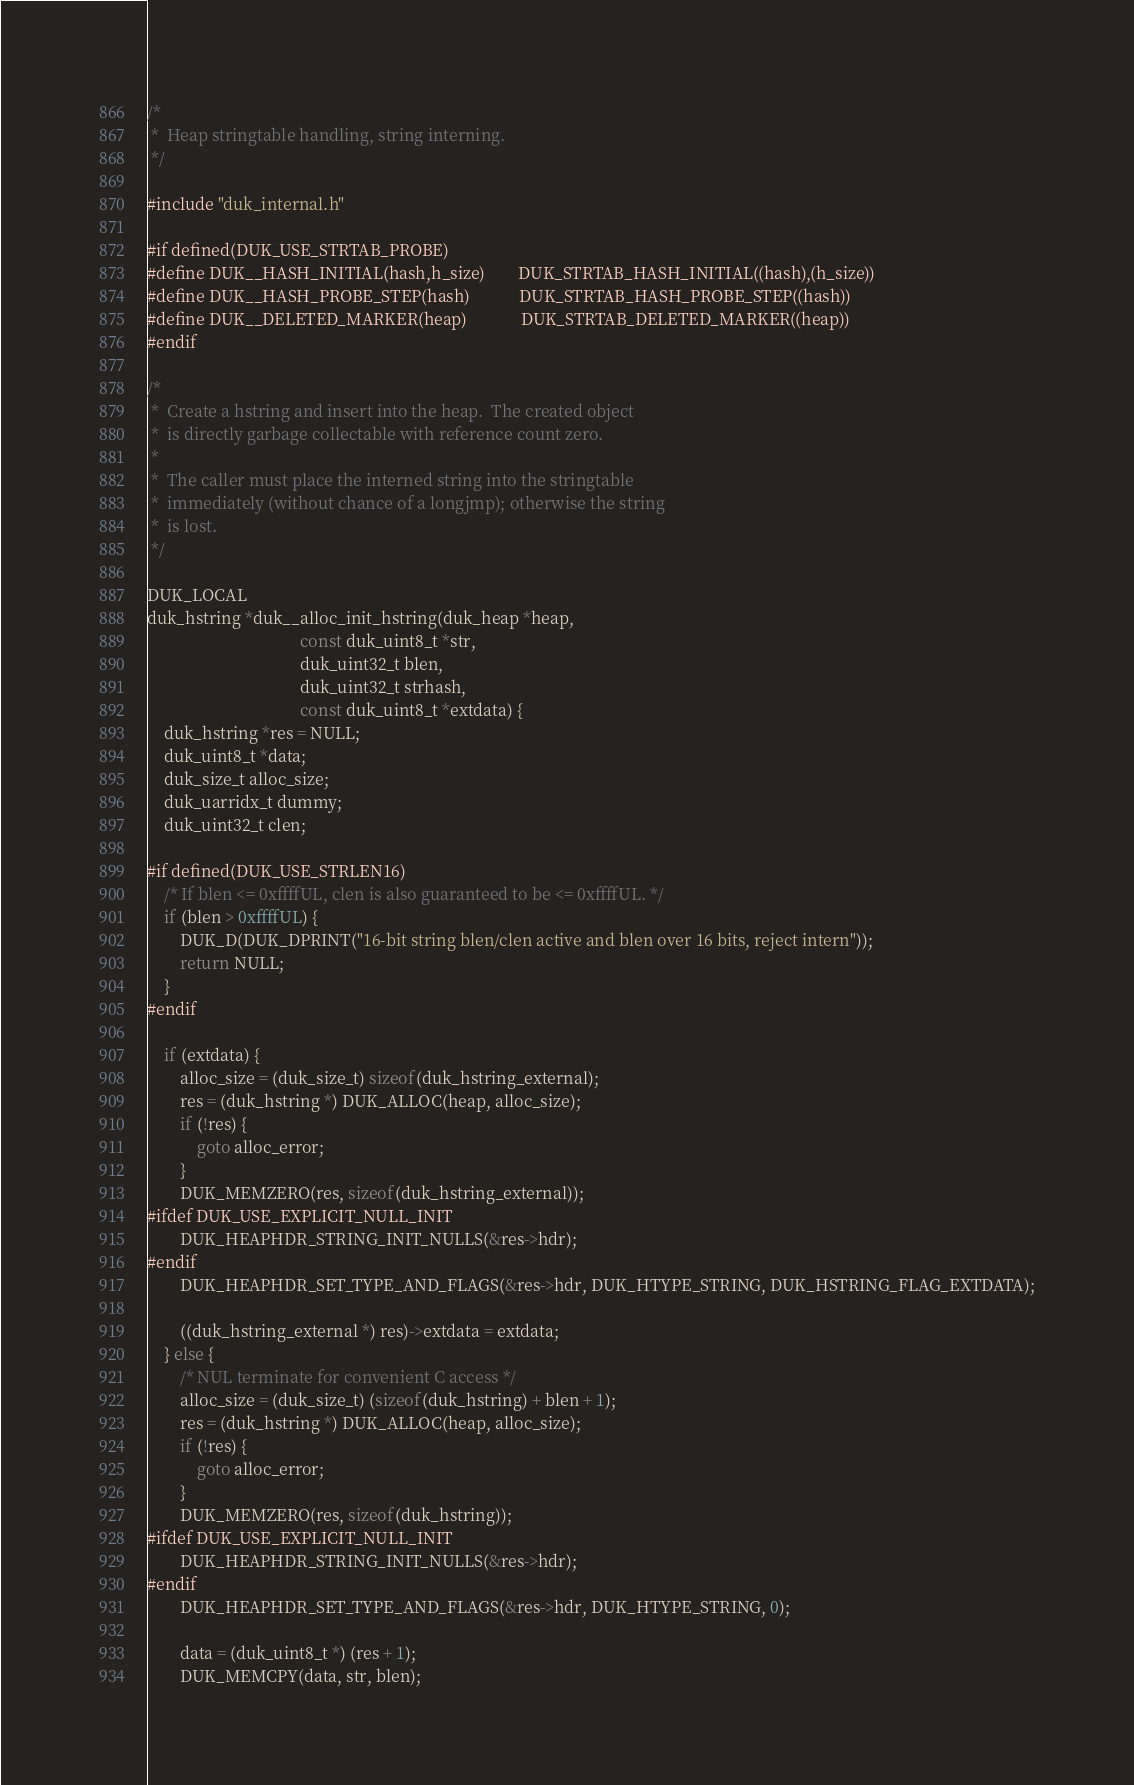<code> <loc_0><loc_0><loc_500><loc_500><_C_>/*
 *  Heap stringtable handling, string interning.
 */

#include "duk_internal.h"

#if defined(DUK_USE_STRTAB_PROBE)
#define DUK__HASH_INITIAL(hash,h_size)        DUK_STRTAB_HASH_INITIAL((hash),(h_size))
#define DUK__HASH_PROBE_STEP(hash)            DUK_STRTAB_HASH_PROBE_STEP((hash))
#define DUK__DELETED_MARKER(heap)             DUK_STRTAB_DELETED_MARKER((heap))
#endif

/*
 *  Create a hstring and insert into the heap.  The created object
 *  is directly garbage collectable with reference count zero.
 *
 *  The caller must place the interned string into the stringtable
 *  immediately (without chance of a longjmp); otherwise the string
 *  is lost.
 */

DUK_LOCAL
duk_hstring *duk__alloc_init_hstring(duk_heap *heap,
                                     const duk_uint8_t *str,
                                     duk_uint32_t blen,
                                     duk_uint32_t strhash,
                                     const duk_uint8_t *extdata) {
	duk_hstring *res = NULL;
	duk_uint8_t *data;
	duk_size_t alloc_size;
	duk_uarridx_t dummy;
	duk_uint32_t clen;

#if defined(DUK_USE_STRLEN16)
	/* If blen <= 0xffffUL, clen is also guaranteed to be <= 0xffffUL. */
	if (blen > 0xffffUL) {
		DUK_D(DUK_DPRINT("16-bit string blen/clen active and blen over 16 bits, reject intern"));
		return NULL;
	}
#endif

	if (extdata) {
		alloc_size = (duk_size_t) sizeof(duk_hstring_external);
		res = (duk_hstring *) DUK_ALLOC(heap, alloc_size);
		if (!res) {
			goto alloc_error;
		}
		DUK_MEMZERO(res, sizeof(duk_hstring_external));
#ifdef DUK_USE_EXPLICIT_NULL_INIT
		DUK_HEAPHDR_STRING_INIT_NULLS(&res->hdr);
#endif
		DUK_HEAPHDR_SET_TYPE_AND_FLAGS(&res->hdr, DUK_HTYPE_STRING, DUK_HSTRING_FLAG_EXTDATA);

		((duk_hstring_external *) res)->extdata = extdata;
	} else {
		/* NUL terminate for convenient C access */
		alloc_size = (duk_size_t) (sizeof(duk_hstring) + blen + 1);
		res = (duk_hstring *) DUK_ALLOC(heap, alloc_size);
		if (!res) {
			goto alloc_error;
		}
		DUK_MEMZERO(res, sizeof(duk_hstring));
#ifdef DUK_USE_EXPLICIT_NULL_INIT
		DUK_HEAPHDR_STRING_INIT_NULLS(&res->hdr);
#endif
		DUK_HEAPHDR_SET_TYPE_AND_FLAGS(&res->hdr, DUK_HTYPE_STRING, 0);

		data = (duk_uint8_t *) (res + 1);
		DUK_MEMCPY(data, str, blen);</code> 